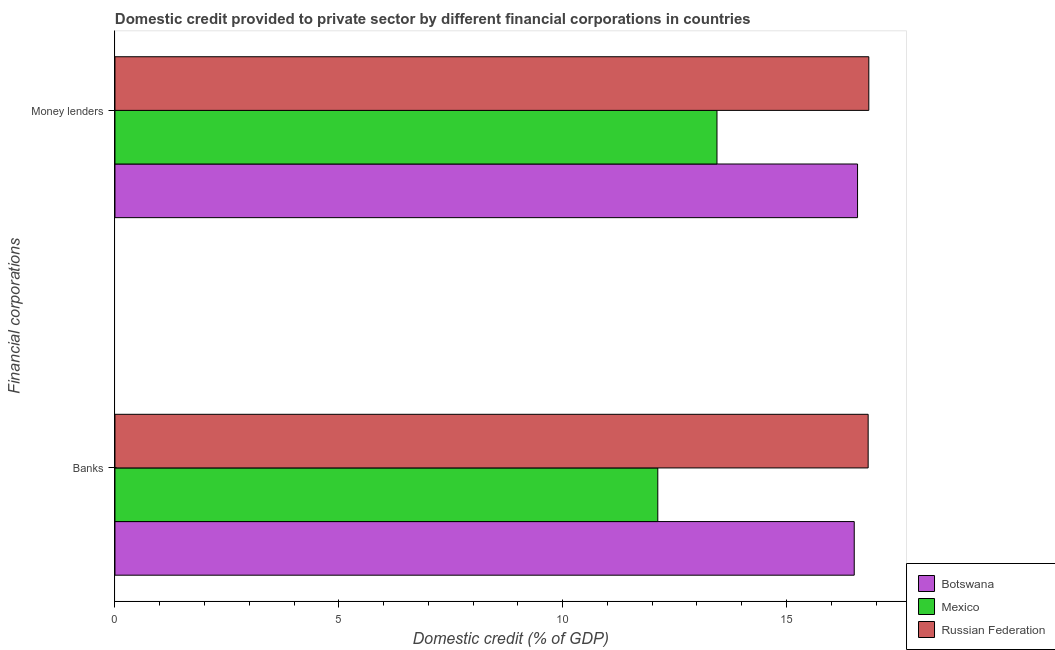How many different coloured bars are there?
Your answer should be very brief. 3. Are the number of bars per tick equal to the number of legend labels?
Your response must be concise. Yes. Are the number of bars on each tick of the Y-axis equal?
Offer a terse response. Yes. How many bars are there on the 1st tick from the bottom?
Give a very brief answer. 3. What is the label of the 1st group of bars from the top?
Offer a very short reply. Money lenders. What is the domestic credit provided by banks in Botswana?
Your answer should be very brief. 16.51. Across all countries, what is the maximum domestic credit provided by money lenders?
Offer a terse response. 16.84. Across all countries, what is the minimum domestic credit provided by banks?
Ensure brevity in your answer.  12.12. In which country was the domestic credit provided by money lenders maximum?
Keep it short and to the point. Russian Federation. In which country was the domestic credit provided by money lenders minimum?
Offer a very short reply. Mexico. What is the total domestic credit provided by banks in the graph?
Give a very brief answer. 45.46. What is the difference between the domestic credit provided by money lenders in Mexico and that in Botswana?
Your response must be concise. -3.14. What is the difference between the domestic credit provided by money lenders in Mexico and the domestic credit provided by banks in Russian Federation?
Keep it short and to the point. -3.38. What is the average domestic credit provided by banks per country?
Keep it short and to the point. 15.15. What is the difference between the domestic credit provided by banks and domestic credit provided by money lenders in Russian Federation?
Your answer should be very brief. -0.01. What is the ratio of the domestic credit provided by money lenders in Russian Federation to that in Mexico?
Make the answer very short. 1.25. In how many countries, is the domestic credit provided by money lenders greater than the average domestic credit provided by money lenders taken over all countries?
Make the answer very short. 2. What does the 2nd bar from the top in Banks represents?
Offer a terse response. Mexico. How many bars are there?
Provide a succinct answer. 6. Are all the bars in the graph horizontal?
Give a very brief answer. Yes. How many countries are there in the graph?
Your answer should be very brief. 3. What is the difference between two consecutive major ticks on the X-axis?
Your response must be concise. 5. Are the values on the major ticks of X-axis written in scientific E-notation?
Your response must be concise. No. How many legend labels are there?
Keep it short and to the point. 3. What is the title of the graph?
Give a very brief answer. Domestic credit provided to private sector by different financial corporations in countries. What is the label or title of the X-axis?
Your answer should be very brief. Domestic credit (% of GDP). What is the label or title of the Y-axis?
Keep it short and to the point. Financial corporations. What is the Domestic credit (% of GDP) in Botswana in Banks?
Your answer should be very brief. 16.51. What is the Domestic credit (% of GDP) in Mexico in Banks?
Give a very brief answer. 12.12. What is the Domestic credit (% of GDP) in Russian Federation in Banks?
Provide a succinct answer. 16.82. What is the Domestic credit (% of GDP) in Botswana in Money lenders?
Offer a terse response. 16.59. What is the Domestic credit (% of GDP) of Mexico in Money lenders?
Make the answer very short. 13.45. What is the Domestic credit (% of GDP) in Russian Federation in Money lenders?
Offer a terse response. 16.84. Across all Financial corporations, what is the maximum Domestic credit (% of GDP) in Botswana?
Offer a very short reply. 16.59. Across all Financial corporations, what is the maximum Domestic credit (% of GDP) of Mexico?
Give a very brief answer. 13.45. Across all Financial corporations, what is the maximum Domestic credit (% of GDP) of Russian Federation?
Provide a short and direct response. 16.84. Across all Financial corporations, what is the minimum Domestic credit (% of GDP) in Botswana?
Provide a short and direct response. 16.51. Across all Financial corporations, what is the minimum Domestic credit (% of GDP) in Mexico?
Your answer should be very brief. 12.12. Across all Financial corporations, what is the minimum Domestic credit (% of GDP) of Russian Federation?
Make the answer very short. 16.82. What is the total Domestic credit (% of GDP) of Botswana in the graph?
Offer a terse response. 33.1. What is the total Domestic credit (% of GDP) of Mexico in the graph?
Your answer should be very brief. 25.57. What is the total Domestic credit (% of GDP) of Russian Federation in the graph?
Your answer should be compact. 33.66. What is the difference between the Domestic credit (% of GDP) of Botswana in Banks and that in Money lenders?
Your answer should be compact. -0.07. What is the difference between the Domestic credit (% of GDP) of Mexico in Banks and that in Money lenders?
Keep it short and to the point. -1.32. What is the difference between the Domestic credit (% of GDP) of Russian Federation in Banks and that in Money lenders?
Give a very brief answer. -0.01. What is the difference between the Domestic credit (% of GDP) in Botswana in Banks and the Domestic credit (% of GDP) in Mexico in Money lenders?
Offer a very short reply. 3.07. What is the difference between the Domestic credit (% of GDP) of Botswana in Banks and the Domestic credit (% of GDP) of Russian Federation in Money lenders?
Offer a very short reply. -0.33. What is the difference between the Domestic credit (% of GDP) of Mexico in Banks and the Domestic credit (% of GDP) of Russian Federation in Money lenders?
Provide a short and direct response. -4.71. What is the average Domestic credit (% of GDP) of Botswana per Financial corporations?
Keep it short and to the point. 16.55. What is the average Domestic credit (% of GDP) of Mexico per Financial corporations?
Make the answer very short. 12.79. What is the average Domestic credit (% of GDP) in Russian Federation per Financial corporations?
Your answer should be very brief. 16.83. What is the difference between the Domestic credit (% of GDP) of Botswana and Domestic credit (% of GDP) of Mexico in Banks?
Your answer should be very brief. 4.39. What is the difference between the Domestic credit (% of GDP) of Botswana and Domestic credit (% of GDP) of Russian Federation in Banks?
Ensure brevity in your answer.  -0.31. What is the difference between the Domestic credit (% of GDP) in Mexico and Domestic credit (% of GDP) in Russian Federation in Banks?
Give a very brief answer. -4.7. What is the difference between the Domestic credit (% of GDP) of Botswana and Domestic credit (% of GDP) of Mexico in Money lenders?
Make the answer very short. 3.14. What is the difference between the Domestic credit (% of GDP) in Botswana and Domestic credit (% of GDP) in Russian Federation in Money lenders?
Give a very brief answer. -0.25. What is the difference between the Domestic credit (% of GDP) in Mexico and Domestic credit (% of GDP) in Russian Federation in Money lenders?
Provide a succinct answer. -3.39. What is the ratio of the Domestic credit (% of GDP) in Mexico in Banks to that in Money lenders?
Give a very brief answer. 0.9. What is the difference between the highest and the second highest Domestic credit (% of GDP) in Botswana?
Ensure brevity in your answer.  0.07. What is the difference between the highest and the second highest Domestic credit (% of GDP) in Mexico?
Provide a short and direct response. 1.32. What is the difference between the highest and the second highest Domestic credit (% of GDP) of Russian Federation?
Your answer should be very brief. 0.01. What is the difference between the highest and the lowest Domestic credit (% of GDP) of Botswana?
Your answer should be compact. 0.07. What is the difference between the highest and the lowest Domestic credit (% of GDP) in Mexico?
Provide a succinct answer. 1.32. What is the difference between the highest and the lowest Domestic credit (% of GDP) of Russian Federation?
Make the answer very short. 0.01. 